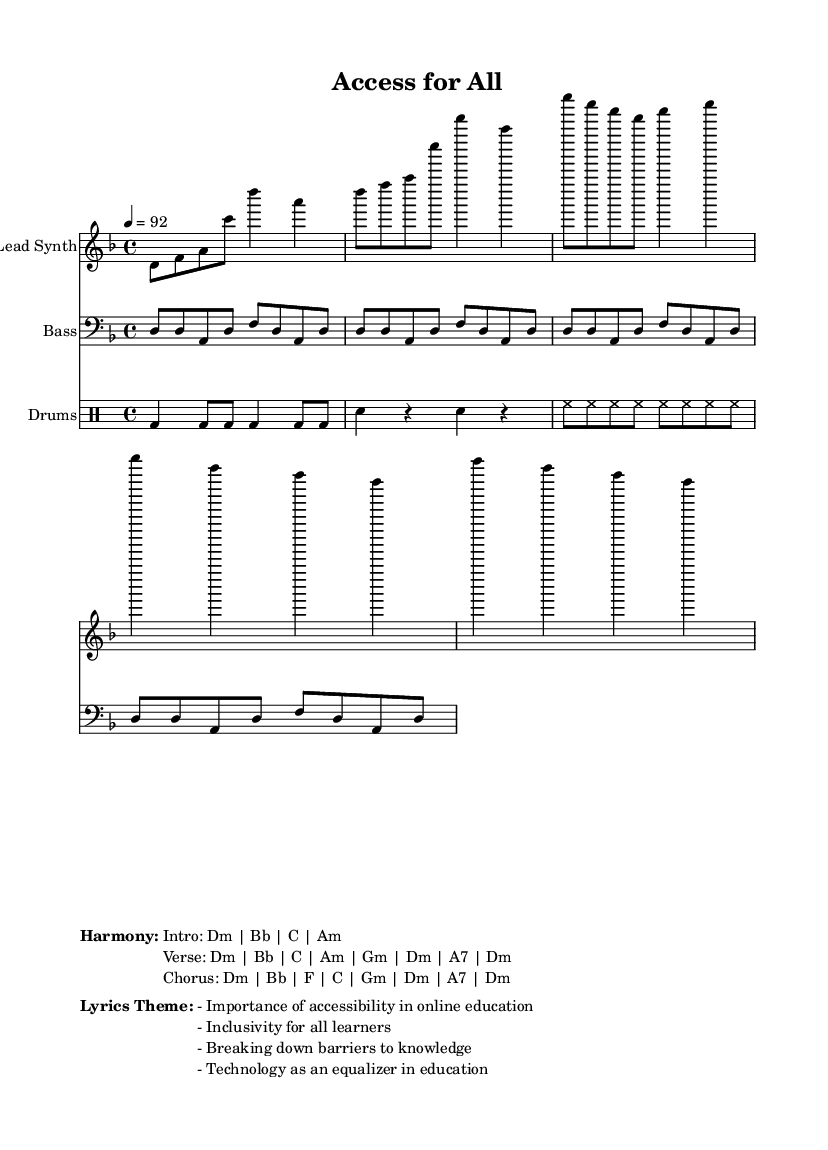What is the key signature of this music? The key signature is D minor, which contains one flat (B flat). This is identified by looking at the beginning of the staff where the key signature is indicated.
Answer: D minor What is the time signature of this piece? The time signature is 4/4, which means there are four beats in each measure and the quarter note gets one beat. This can be found at the beginning of the sheet music after the key signature.
Answer: 4/4 What is the tempo for this music? The tempo is set at 92 beats per minute. This is usually noted above the staff as "4 = 92", indicating how many beats per minute the quarter note should receive.
Answer: 92 How many measures are in the lead synth part? The lead synth part consists of 8 measures. This can be counted by identifying the vertical lines that separate the measures in the staff notation.
Answer: 8 What is the main theme of the lyrics in this music? The main theme of the lyrics highlights the importance of accessibility in online education. This is summarized in the lyrics theme section provided at the bottom of the music sheet.
Answer: Importance of accessibility in online education What is the first chord played in the intro? The first chord played in the intro is D minor. This can be determined by analyzing the chord progression indicated in the harmony section.
Answer: D minor What instrument plays the bass part? The bass part is played on a bass instrument, often specified in the music staff by including the clef sign for bass. This is seen in the staff corresponding to the bass part.
Answer: Bass 